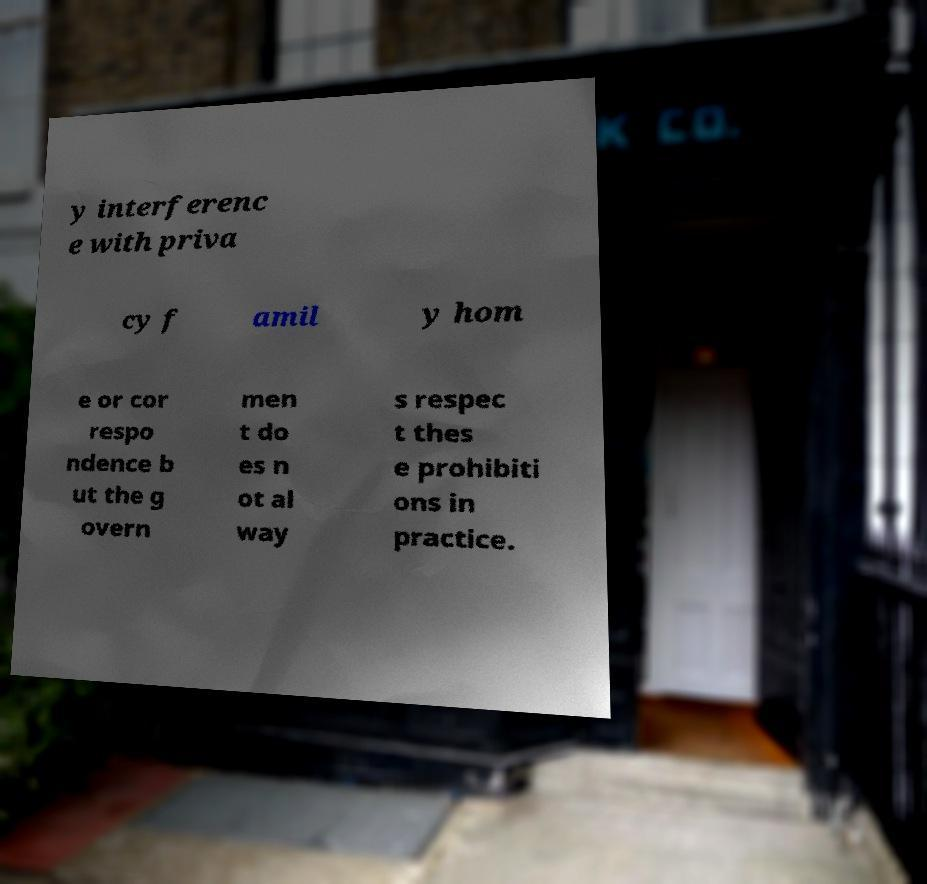Could you assist in decoding the text presented in this image and type it out clearly? y interferenc e with priva cy f amil y hom e or cor respo ndence b ut the g overn men t do es n ot al way s respec t thes e prohibiti ons in practice. 